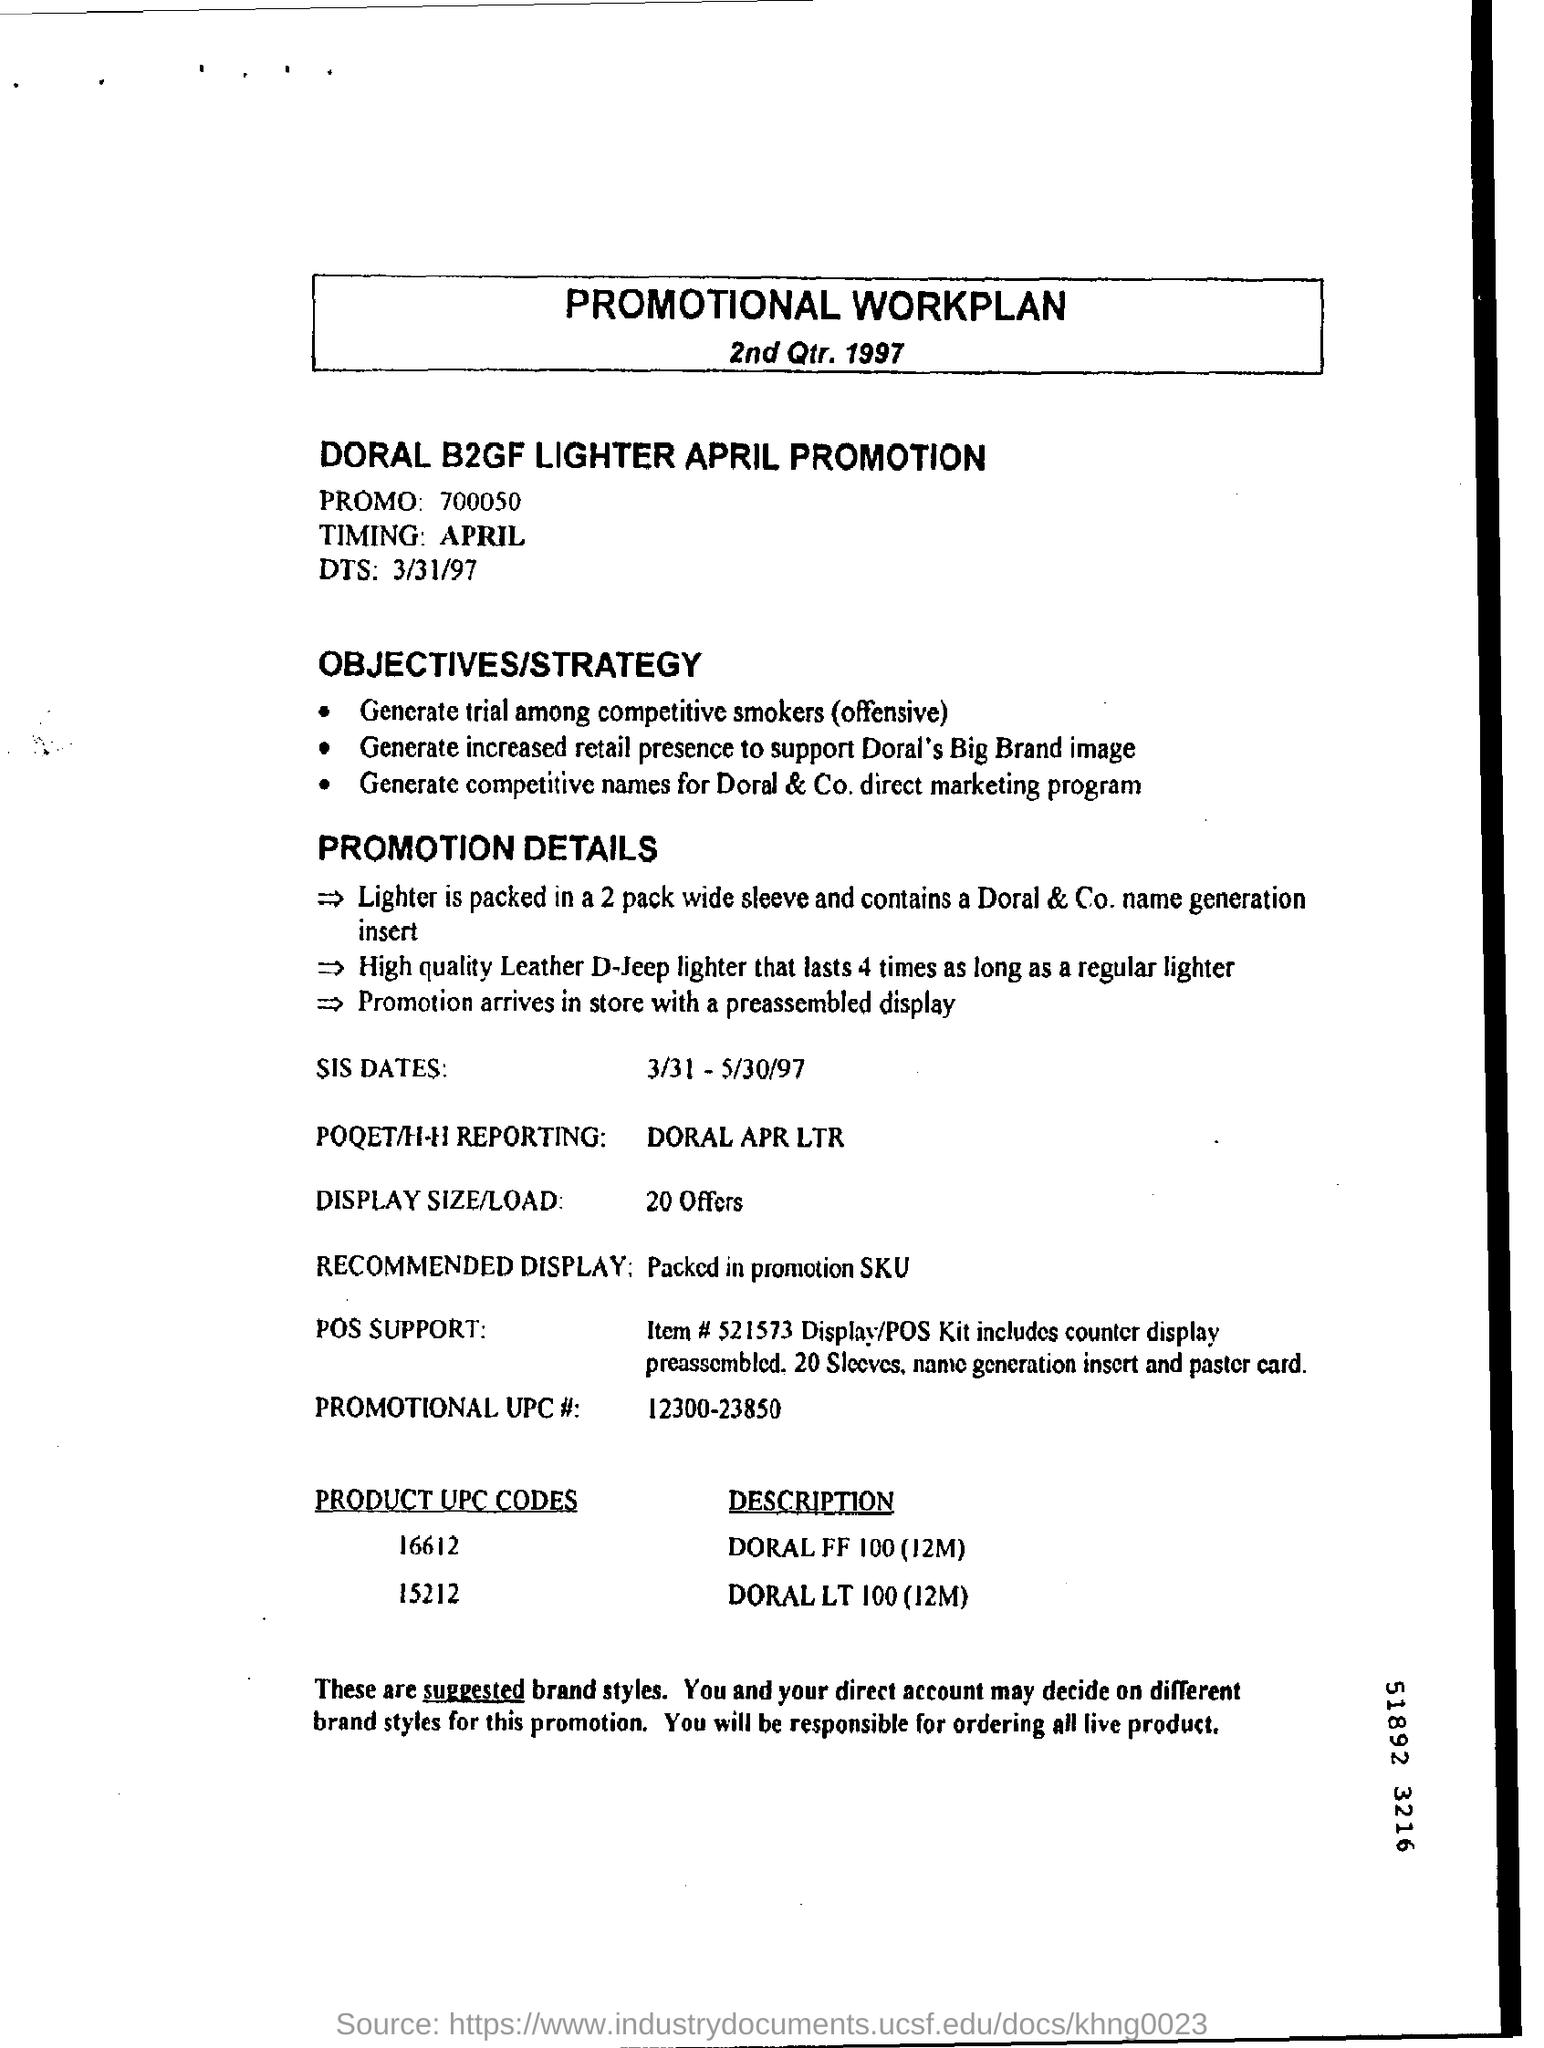What is "timing" mentioned? The timing mentioned in the document for the DORAL B2GF LIGHTER APRIL PROMOTION is scheduled for 'April'. This promotion was planned as per the details outlined with specific dates from 3/31/97 to 5/30/97. 